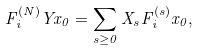Convert formula to latex. <formula><loc_0><loc_0><loc_500><loc_500>F _ { i } ^ { ( N ) } Y x _ { 0 } = \sum _ { s \geq 0 } X _ { s } F _ { i } ^ { ( s ) } x _ { 0 } ,</formula> 